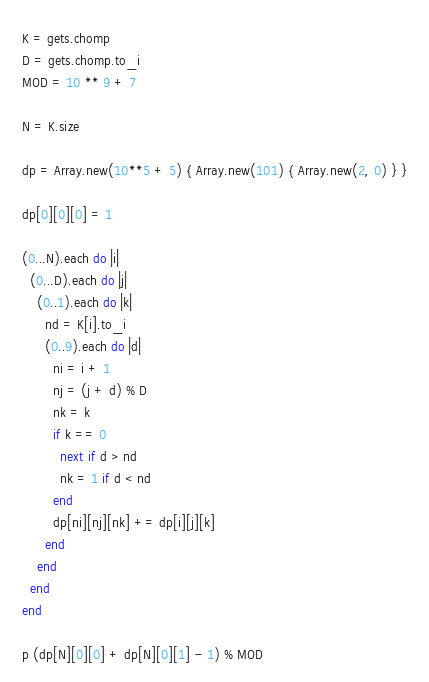<code> <loc_0><loc_0><loc_500><loc_500><_Ruby_>K = gets.chomp
D = gets.chomp.to_i
MOD = 10 ** 9 + 7

N = K.size

dp = Array.new(10**5 + 5) { Array.new(101) { Array.new(2, 0) } }

dp[0][0][0] = 1

(0...N).each do |i|
  (0...D).each do |j|
    (0..1).each do |k|
      nd = K[i].to_i
      (0..9).each do |d|
        ni = i + 1
        nj = (j + d) % D
        nk = k
        if k == 0
          next if d > nd
          nk = 1 if d < nd
        end
        dp[ni][nj][nk] += dp[i][j][k]
      end
    end
  end
end

p (dp[N][0][0] + dp[N][0][1] - 1) % MOD
</code> 